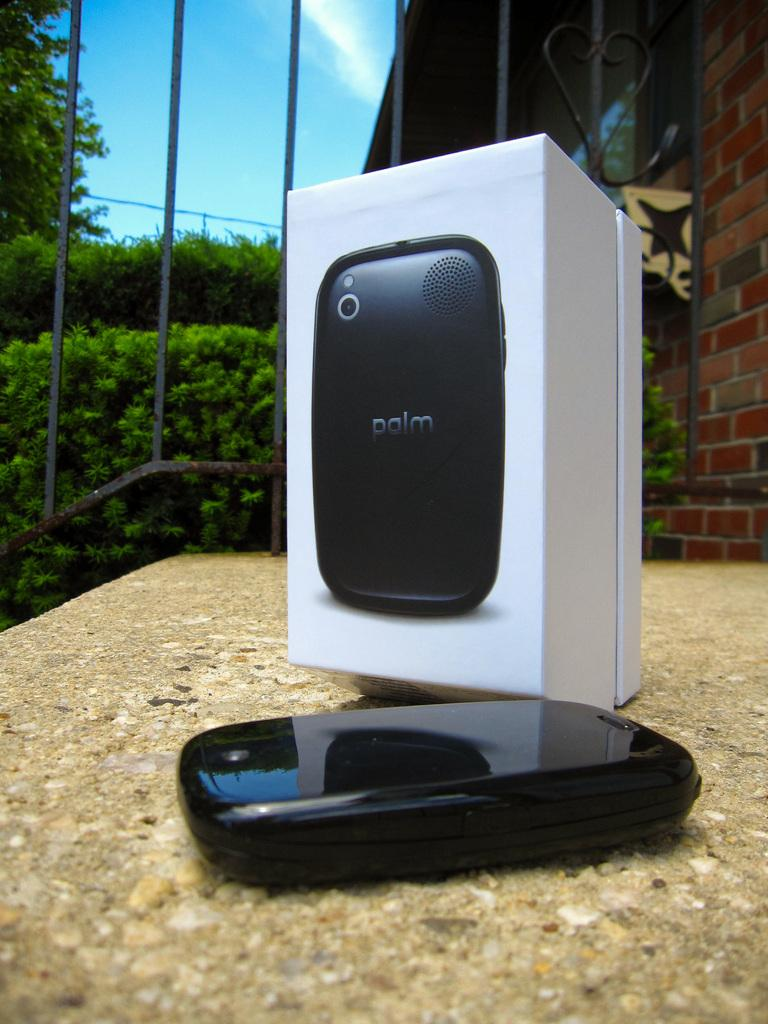<image>
Write a terse but informative summary of the picture. an object with a speaker and palm wrote on it 